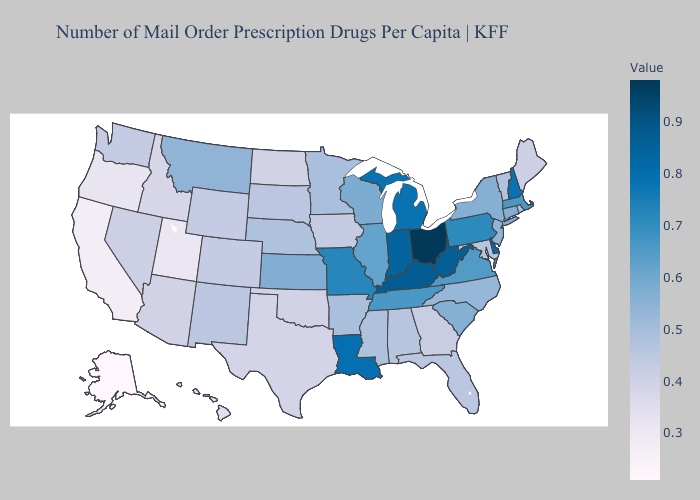Does Delaware have the lowest value in the South?
Answer briefly. No. Does Ohio have the highest value in the USA?
Short answer required. Yes. Does Ohio have the highest value in the USA?
Concise answer only. Yes. Which states hav the highest value in the MidWest?
Answer briefly. Ohio. Does Arizona have a higher value than South Carolina?
Answer briefly. No. 